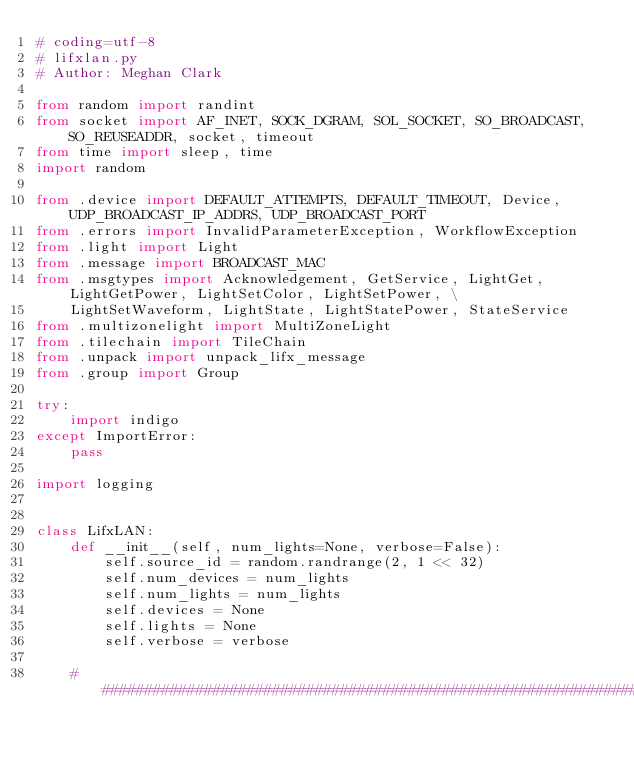Convert code to text. <code><loc_0><loc_0><loc_500><loc_500><_Python_># coding=utf-8
# lifxlan.py
# Author: Meghan Clark

from random import randint
from socket import AF_INET, SOCK_DGRAM, SOL_SOCKET, SO_BROADCAST, SO_REUSEADDR, socket, timeout
from time import sleep, time
import random

from .device import DEFAULT_ATTEMPTS, DEFAULT_TIMEOUT, Device, UDP_BROADCAST_IP_ADDRS, UDP_BROADCAST_PORT
from .errors import InvalidParameterException, WorkflowException
from .light import Light
from .message import BROADCAST_MAC
from .msgtypes import Acknowledgement, GetService, LightGet, LightGetPower, LightSetColor, LightSetPower, \
    LightSetWaveform, LightState, LightStatePower, StateService
from .multizonelight import MultiZoneLight
from .tilechain import TileChain
from .unpack import unpack_lifx_message
from .group import Group

try:
    import indigo
except ImportError:
    pass

import logging


class LifxLAN:
    def __init__(self, num_lights=None, verbose=False):
        self.source_id = random.randrange(2, 1 << 32)
        self.num_devices = num_lights
        self.num_lights = num_lights
        self.devices = None
        self.lights = None
        self.verbose = verbose

    ############################################################################</code> 